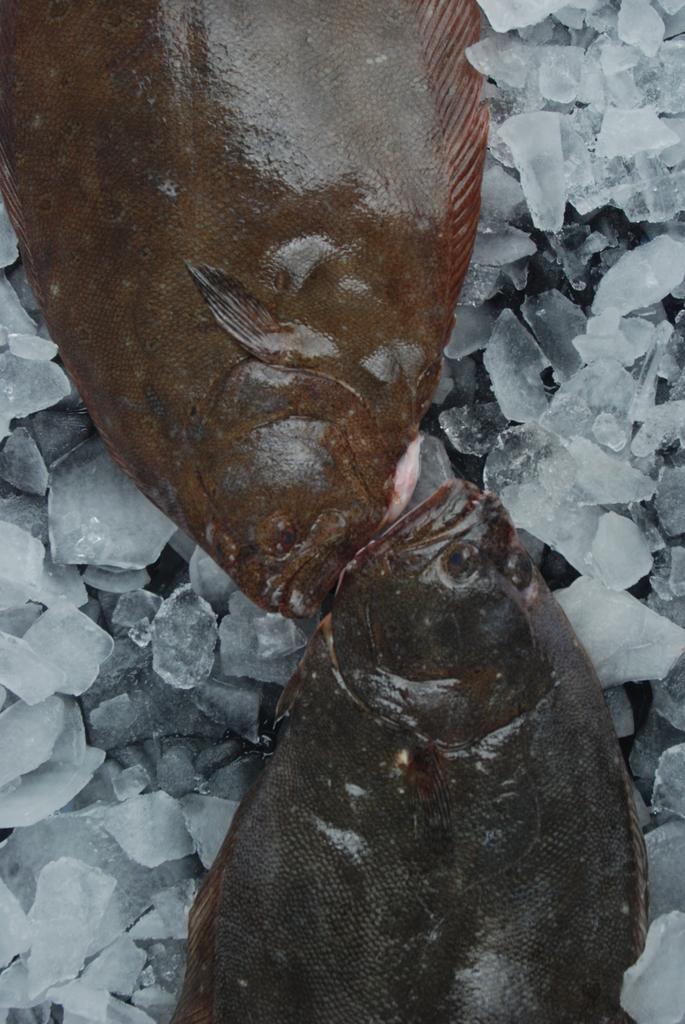Could you give a brief overview of what you see in this image? In this image we can see fishes and ice pieces. 